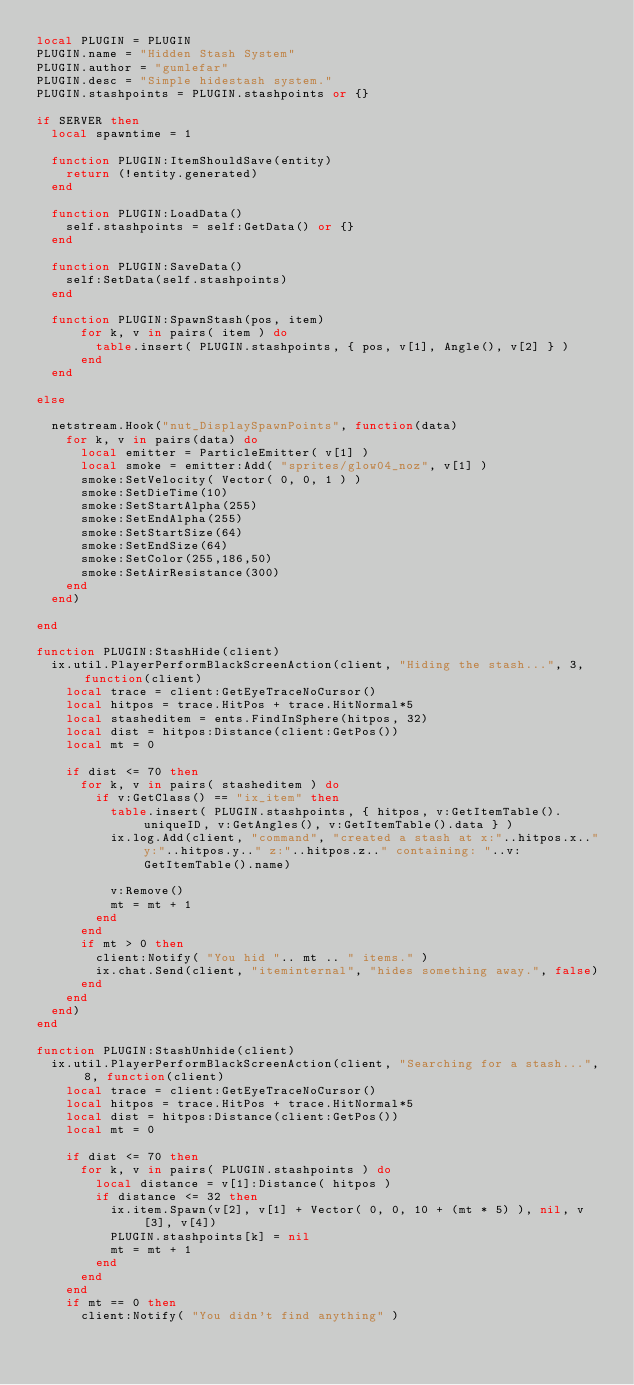Convert code to text. <code><loc_0><loc_0><loc_500><loc_500><_Lua_>local PLUGIN = PLUGIN
PLUGIN.name = "Hidden Stash System"
PLUGIN.author = "gumlefar"
PLUGIN.desc = "Simple hidestash system."
PLUGIN.stashpoints = PLUGIN.stashpoints or {}

if SERVER then
	local spawntime = 1

	function PLUGIN:ItemShouldSave(entity)
		return (!entity.generated)
	end

	function PLUGIN:LoadData()
		self.stashpoints = self:GetData() or {}
	end

	function PLUGIN:SaveData()
		self:SetData(self.stashpoints)
	end

	function PLUGIN:SpawnStash(pos, item)
  		for k, v in pairs( item ) do
    		table.insert( PLUGIN.stashpoints, { pos, v[1], Angle(), v[2] } )
  		end
	end

else

	netstream.Hook("nut_DisplaySpawnPoints", function(data)
		for k, v in pairs(data) do
			local emitter = ParticleEmitter( v[1] )
			local smoke = emitter:Add( "sprites/glow04_noz", v[1] )
			smoke:SetVelocity( Vector( 0, 0, 1 ) )
			smoke:SetDieTime(10)
			smoke:SetStartAlpha(255)
			smoke:SetEndAlpha(255)
			smoke:SetStartSize(64)
			smoke:SetEndSize(64)
			smoke:SetColor(255,186,50)
			smoke:SetAirResistance(300)
		end
	end)

end

function PLUGIN:StashHide(client)
	ix.util.PlayerPerformBlackScreenAction(client, "Hiding the stash...", 3, function(client) 
		local trace = client:GetEyeTraceNoCursor()
		local hitpos = trace.HitPos + trace.HitNormal*5
		local stasheditem = ents.FindInSphere(hitpos, 32)
		local dist = hitpos:Distance(client:GetPos())
		local mt = 0
		
		if dist <= 70 then
			for k, v in pairs( stasheditem ) do
				if v:GetClass() == "ix_item" then
					table.insert( PLUGIN.stashpoints, { hitpos, v:GetItemTable().uniqueID, v:GetAngles(), v:GetItemTable().data } )
					ix.log.Add(client, "command", "created a stash at x:"..hitpos.x.." y:"..hitpos.y.." z:"..hitpos.z.." containing: "..v:GetItemTable().name)

					v:Remove()
					mt = mt + 1
				end
			end
			if mt > 0 then
				client:Notify( "You hid ".. mt .. " items." )
				ix.chat.Send(client, "iteminternal", "hides something away.", false)
			end
		end
	end)
end

function PLUGIN:StashUnhide(client)
	ix.util.PlayerPerformBlackScreenAction(client, "Searching for a stash...", 8, function(client) 
		local trace = client:GetEyeTraceNoCursor()
		local hitpos = trace.HitPos + trace.HitNormal*5
		local dist = hitpos:Distance(client:GetPos())
		local mt = 0
		
		if dist <= 70 then
			for k, v in pairs( PLUGIN.stashpoints ) do
				local distance = v[1]:Distance( hitpos )
				if distance <= 32 then
					ix.item.Spawn(v[2], v[1] + Vector( 0, 0, 10 + (mt * 5) ), nil, v[3], v[4])
					PLUGIN.stashpoints[k] = nil
					mt = mt + 1
				end
			end
		end
		if mt == 0 then
			client:Notify( "You didn't find anything" )</code> 